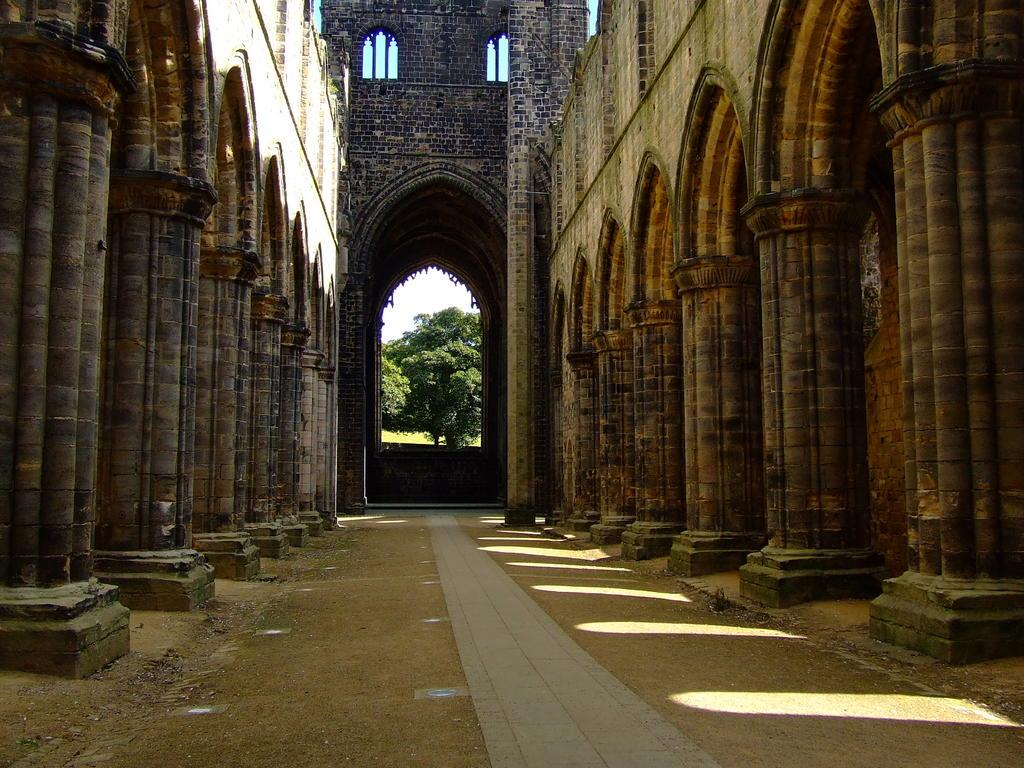What is the main structure in the center of the image? There is a tower in the center of the image. What architectural features can be seen around the tower? There are pillars visible in the image. What type of entrance is present at the bottom of the image? There is an arch at the bottom of the image. What type of vegetation is present in the image? There is a tree in the image. What can be seen in the background of the image? The sky is visible in the background of the image. What type of insurance policy is being discussed in the image? There is no discussion of insurance policies in the image; it features a tower, pillars, an arch, a tree, and the sky. 